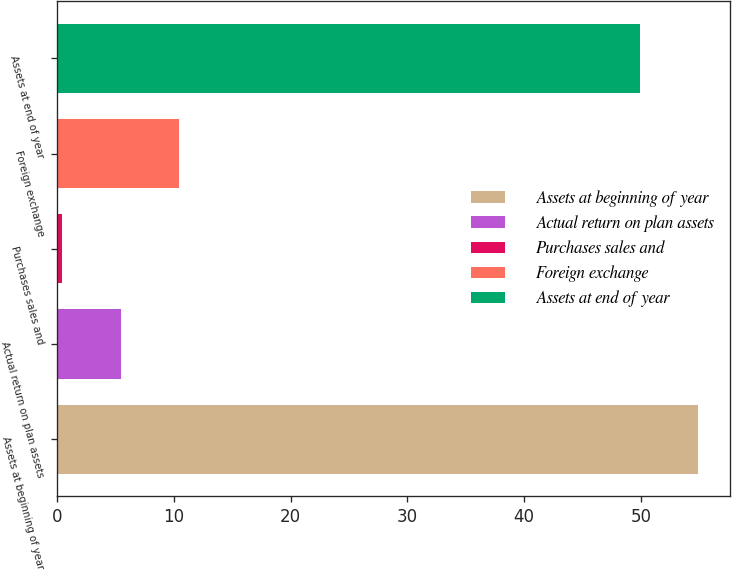<chart> <loc_0><loc_0><loc_500><loc_500><bar_chart><fcel>Assets at beginning of year<fcel>Actual return on plan assets<fcel>Purchases sales and<fcel>Foreign exchange<fcel>Assets at end of year<nl><fcel>54.94<fcel>5.44<fcel>0.4<fcel>10.48<fcel>49.9<nl></chart> 